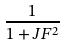<formula> <loc_0><loc_0><loc_500><loc_500>\frac { 1 } { 1 + J F ^ { 2 } }</formula> 